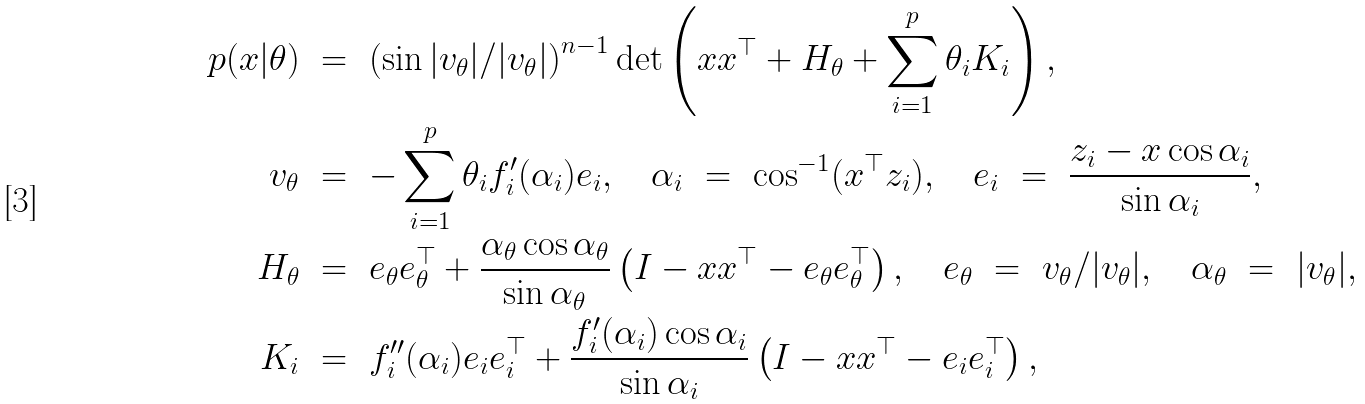Convert formula to latex. <formula><loc_0><loc_0><loc_500><loc_500>p ( x | \theta ) & \ = \ \left ( \sin | v _ { \theta } | / | v _ { \theta } | \right ) ^ { n - 1 } \det \left ( x x ^ { \top } + H _ { \theta } + \sum _ { i = 1 } ^ { p } \theta _ { i } K _ { i } \right ) , \\ v _ { \theta } & \ = \ - \sum _ { i = 1 } ^ { p } \theta _ { i } f _ { i } ^ { \prime } ( \alpha _ { i } ) e _ { i } , \quad \alpha _ { i } \ = \ \cos ^ { - 1 } ( x ^ { \top } z _ { i } ) , \quad e _ { i } \ = \ \frac { z _ { i } - x \cos \alpha _ { i } } { \sin \alpha _ { i } } , \\ H _ { \theta } & \ = \ e _ { \theta } e _ { \theta } ^ { \top } + \frac { \alpha _ { \theta } \cos \alpha _ { \theta } } { \sin \alpha _ { \theta } } \left ( I - x x ^ { \top } - e _ { \theta } e _ { \theta } ^ { \top } \right ) , \quad e _ { \theta } \ = \ v _ { \theta } / | v _ { \theta } | , \quad \alpha _ { \theta } \ = \ | v _ { \theta } | , \\ \quad K _ { i } & \ = \ f _ { i } ^ { \prime \prime } ( \alpha _ { i } ) e _ { i } e _ { i } ^ { \top } + \frac { f _ { i } ^ { \prime } ( \alpha _ { i } ) \cos \alpha _ { i } } { \sin \alpha _ { i } } \left ( I - x x ^ { \top } - e _ { i } e _ { i } ^ { \top } \right ) ,</formula> 